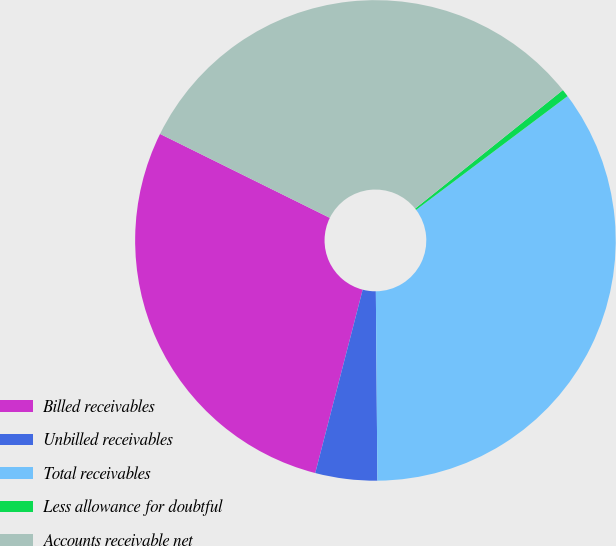Convert chart. <chart><loc_0><loc_0><loc_500><loc_500><pie_chart><fcel>Billed receivables<fcel>Unbilled receivables<fcel>Total receivables<fcel>Less allowance for doubtful<fcel>Accounts receivable net<nl><fcel>28.28%<fcel>4.16%<fcel>35.12%<fcel>0.51%<fcel>31.93%<nl></chart> 